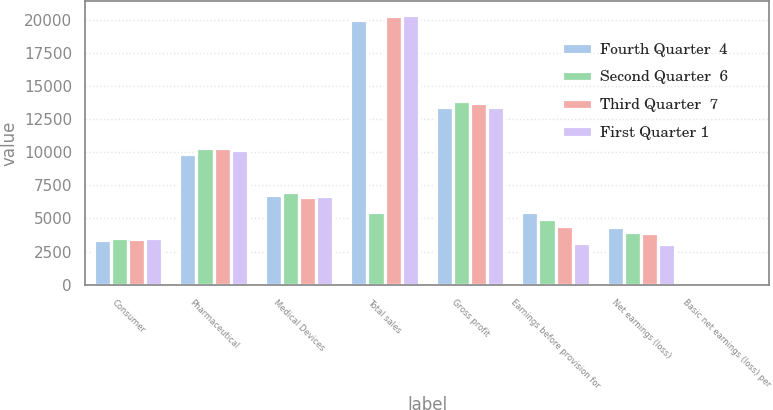<chart> <loc_0><loc_0><loc_500><loc_500><stacked_bar_chart><ecel><fcel>Consumer<fcel>Pharmaceutical<fcel>Medical Devices<fcel>Total sales<fcel>Gross profit<fcel>Earnings before provision for<fcel>Net earnings (loss)<fcel>Basic net earnings (loss) per<nl><fcel>Fourth Quarter  4<fcel>3398<fcel>9844<fcel>6767<fcel>20009<fcel>13395<fcel>5481<fcel>4367<fcel>1.63<nl><fcel>Second Quarter  6<fcel>3504<fcel>10354<fcel>6972<fcel>5481<fcel>13903<fcel>4973<fcel>3954<fcel>1.47<nl><fcel>Third Quarter  7<fcel>3415<fcel>10346<fcel>6587<fcel>20348<fcel>13759<fcel>4423<fcel>3934<fcel>1.47<nl><fcel>First Quarter 1<fcel>3536<fcel>10190<fcel>6668<fcel>20394<fcel>13433<fcel>3122<fcel>3042<fcel>1.14<nl></chart> 